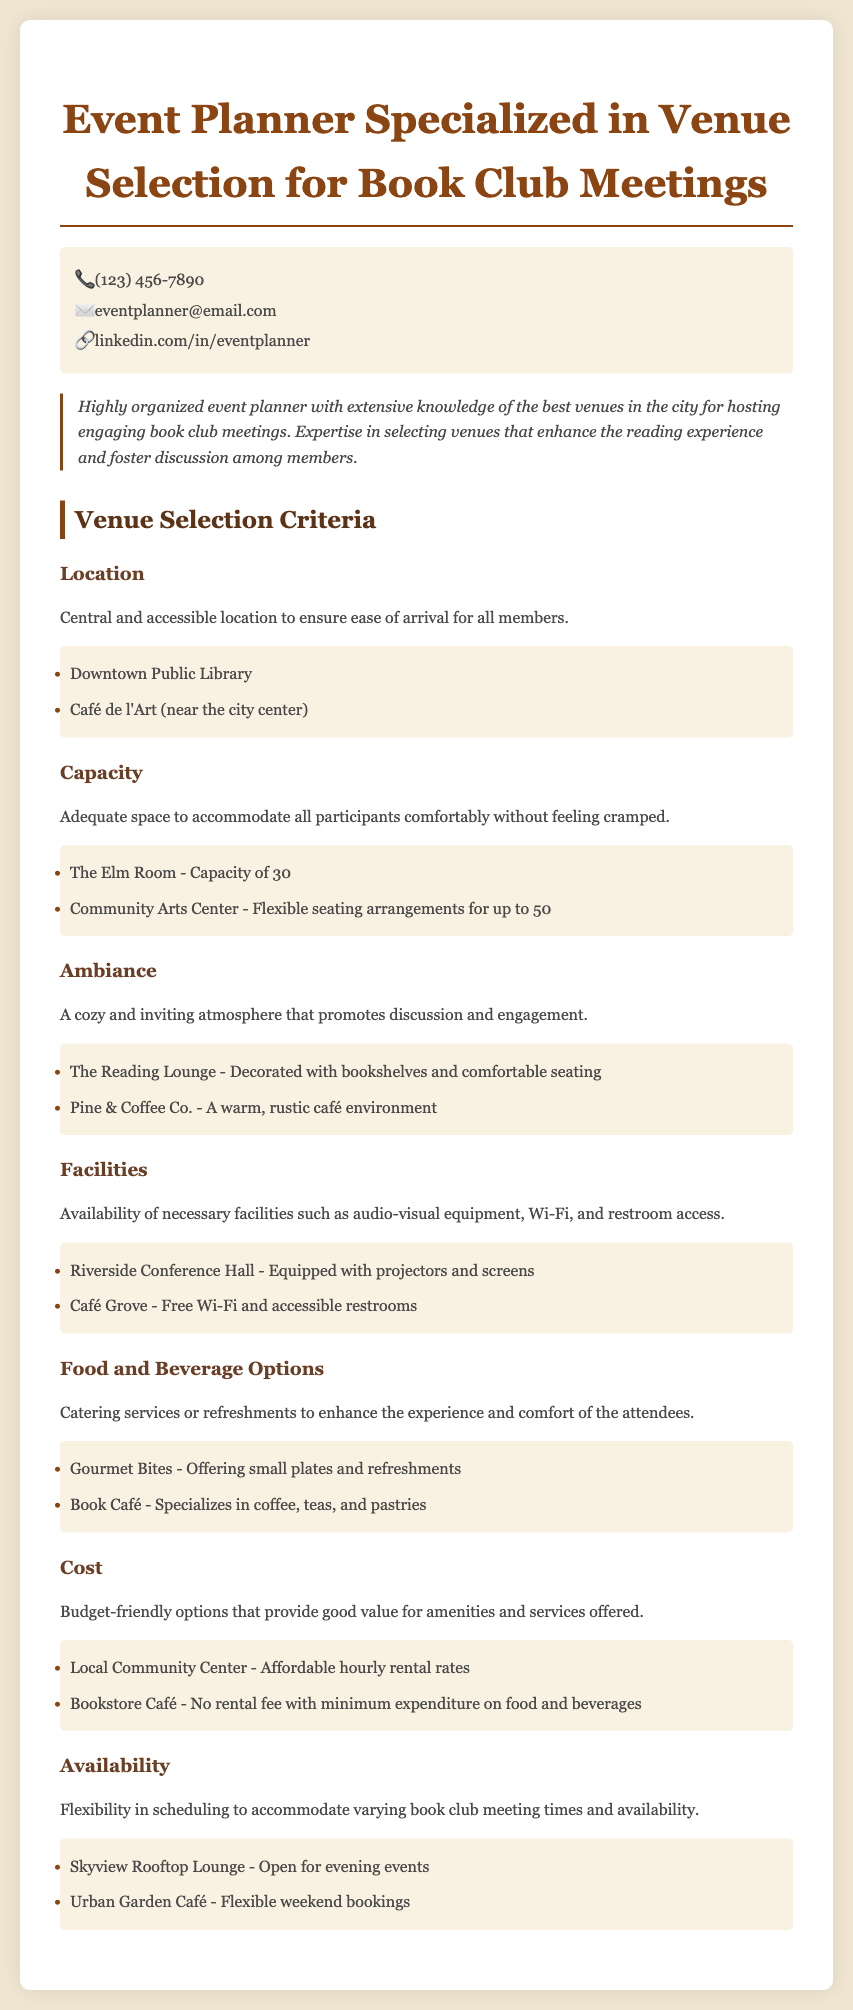What is the primary expertise of the event planner? The event planner specializes in selecting venues for book club meetings, enhancing the reading experience, and fostering discussion.
Answer: Venue selection for book club meetings How many examples are provided for food and beverage options? There are two examples listed under the food and beverage options criterion.
Answer: 2 What is the location of the Downtown Public Library? The Downtown Public Library is centrally located for ease of arrival.
Answer: Central What type of ambiance is preferred for book club meetings? A cozy and inviting atmosphere is desired to promote discussion and engagement.
Answer: Cozy and inviting What is the capacity of The Elm Room? The Elm Room can accommodate 30 people comfortably.
Answer: 30 Which venue is noted for offering refreshments? Gourmet Bites is mentioned for offering small plates and refreshments.
Answer: Gourmet Bites What is the cost consideration for venue selection? Budget-friendly options that provide good value for amenities and services are considered.
Answer: Budget-friendly How flexible is the Urban Garden Café regarding bookings? The Urban Garden Café is indicated to have flexible weekend bookings.
Answer: Flexible weekend bookings What color is used in the section headings? The section headings are styled in earthy tones, specifically brownish shades.
Answer: Brownish shades 